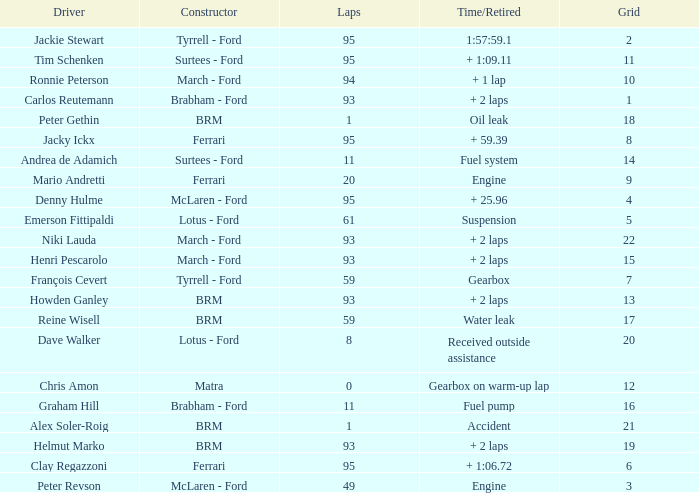Give me the full table as a dictionary. {'header': ['Driver', 'Constructor', 'Laps', 'Time/Retired', 'Grid'], 'rows': [['Jackie Stewart', 'Tyrrell - Ford', '95', '1:57:59.1', '2'], ['Tim Schenken', 'Surtees - Ford', '95', '+ 1:09.11', '11'], ['Ronnie Peterson', 'March - Ford', '94', '+ 1 lap', '10'], ['Carlos Reutemann', 'Brabham - Ford', '93', '+ 2 laps', '1'], ['Peter Gethin', 'BRM', '1', 'Oil leak', '18'], ['Jacky Ickx', 'Ferrari', '95', '+ 59.39', '8'], ['Andrea de Adamich', 'Surtees - Ford', '11', 'Fuel system', '14'], ['Mario Andretti', 'Ferrari', '20', 'Engine', '9'], ['Denny Hulme', 'McLaren - Ford', '95', '+ 25.96', '4'], ['Emerson Fittipaldi', 'Lotus - Ford', '61', 'Suspension', '5'], ['Niki Lauda', 'March - Ford', '93', '+ 2 laps', '22'], ['Henri Pescarolo', 'March - Ford', '93', '+ 2 laps', '15'], ['François Cevert', 'Tyrrell - Ford', '59', 'Gearbox', '7'], ['Howden Ganley', 'BRM', '93', '+ 2 laps', '13'], ['Reine Wisell', 'BRM', '59', 'Water leak', '17'], ['Dave Walker', 'Lotus - Ford', '8', 'Received outside assistance', '20'], ['Chris Amon', 'Matra', '0', 'Gearbox on warm-up lap', '12'], ['Graham Hill', 'Brabham - Ford', '11', 'Fuel pump', '16'], ['Alex Soler-Roig', 'BRM', '1', 'Accident', '21'], ['Helmut Marko', 'BRM', '93', '+ 2 laps', '19'], ['Clay Regazzoni', 'Ferrari', '95', '+ 1:06.72', '6'], ['Peter Revson', 'McLaren - Ford', '49', 'Engine', '3']]} How many grids does dave walker have? 1.0. 